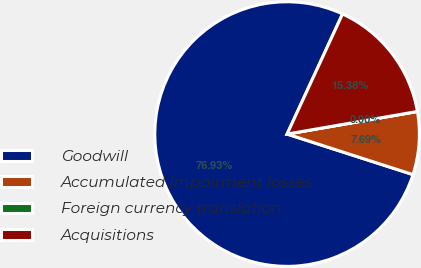Convert chart to OTSL. <chart><loc_0><loc_0><loc_500><loc_500><pie_chart><fcel>Goodwill<fcel>Accumulated impairment losses<fcel>Foreign currency translation<fcel>Acquisitions<nl><fcel>76.92%<fcel>7.69%<fcel>0.0%<fcel>15.38%<nl></chart> 